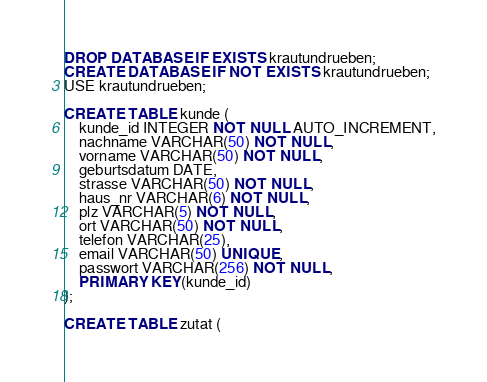Convert code to text. <code><loc_0><loc_0><loc_500><loc_500><_SQL_>DROP DATABASE IF EXISTS krautundrueben;
CREATE DATABASE IF NOT EXISTS krautundrueben;
USE krautundrueben;

CREATE TABLE kunde (
    kunde_id INTEGER NOT NULL AUTO_INCREMENT,
    nachname VARCHAR(50) NOT NULL,
    vorname VARCHAR(50) NOT NULL,
    geburtsdatum DATE,
    strasse VARCHAR(50) NOT NULL,
    haus_nr VARCHAR(6) NOT NULL,
    plz VARCHAR(5) NOT NULL,
    ort VARCHAR(50) NOT NULL,
    telefon VARCHAR(25),
    email VARCHAR(50) UNIQUE,
    passwort VARCHAR(256) NOT NULL,
    PRIMARY KEY(kunde_id)
);

CREATE TABLE zutat (</code> 